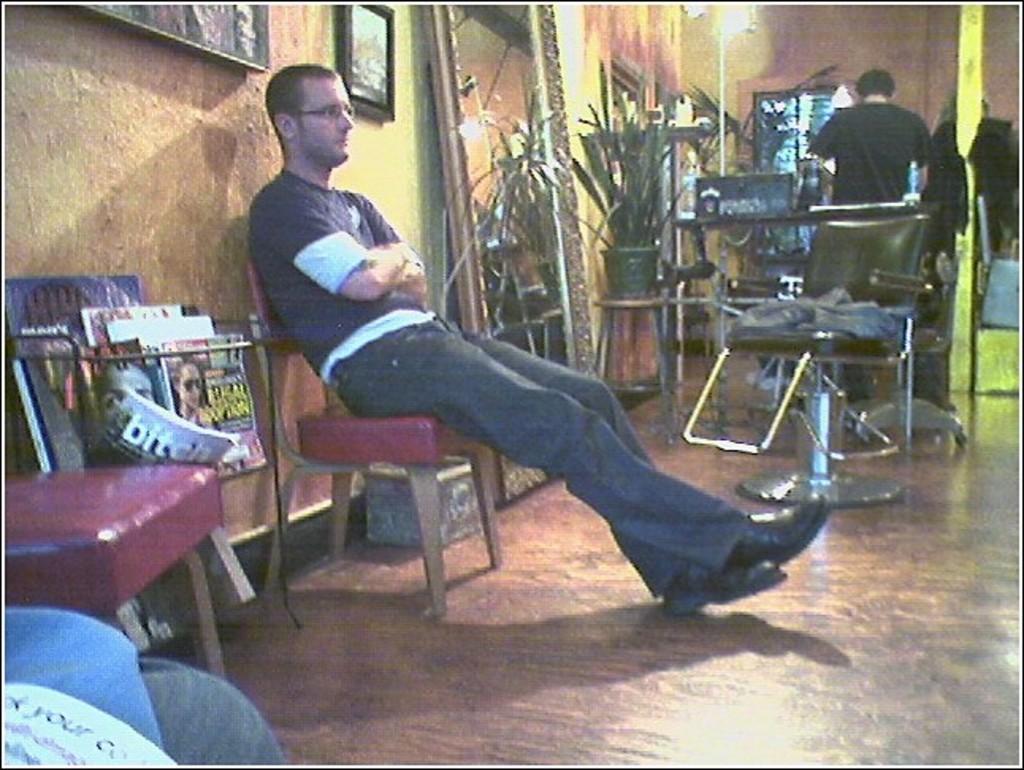How would you summarize this image in a sentence or two? in a room a person is sitting and another person is standing there are many things present in the room 